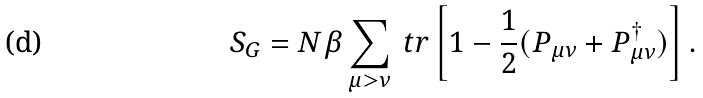Convert formula to latex. <formula><loc_0><loc_0><loc_500><loc_500>S _ { G } = N \beta \sum _ { \mu > \nu } \ t r \left [ 1 - \frac { 1 } { 2 } ( P _ { \mu \nu } + P _ { \mu \nu } ^ { \dag } ) \right ] .</formula> 